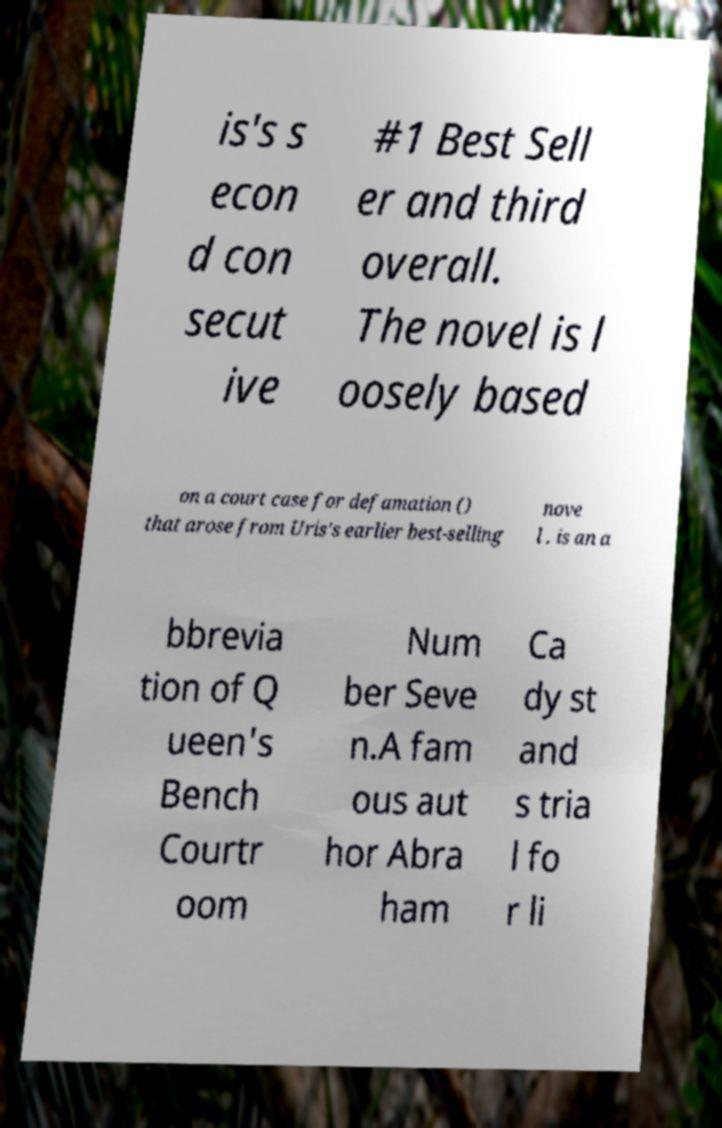For documentation purposes, I need the text within this image transcribed. Could you provide that? is's s econ d con secut ive #1 Best Sell er and third overall. The novel is l oosely based on a court case for defamation () that arose from Uris's earlier best-selling nove l . is an a bbrevia tion of Q ueen's Bench Courtr oom Num ber Seve n.A fam ous aut hor Abra ham Ca dy st and s tria l fo r li 